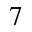Convert formula to latex. <formula><loc_0><loc_0><loc_500><loc_500>7</formula> 